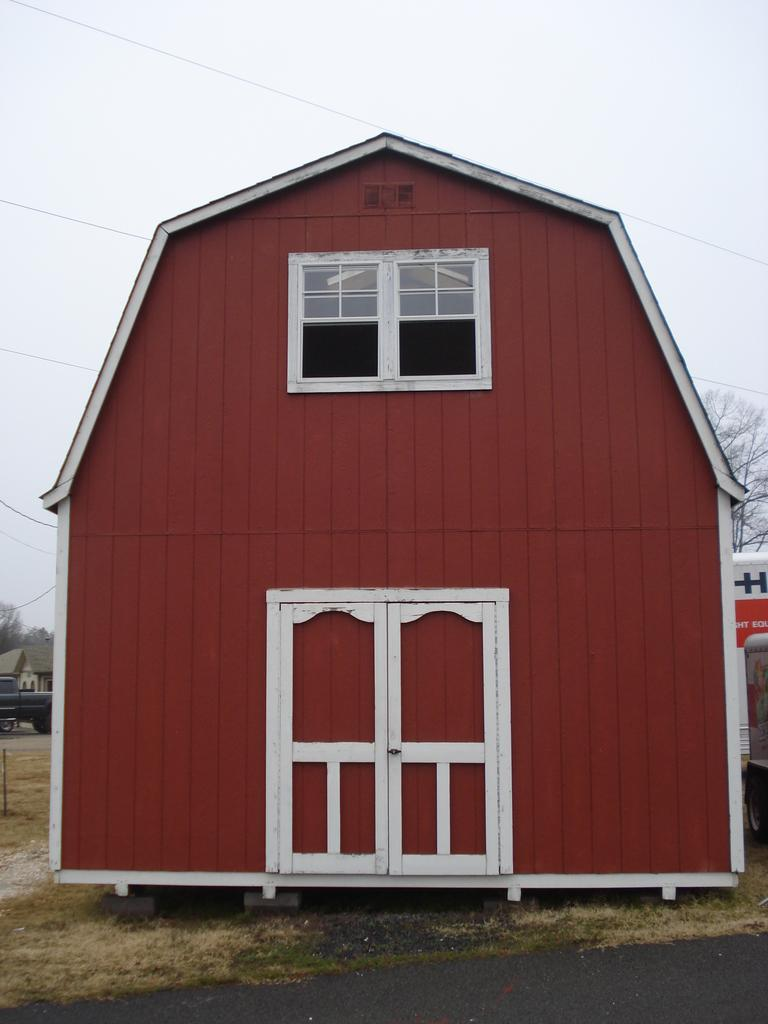What is the main structure in the front of the image? There is a house in the front of the image. What can be seen in the background of the image? There are trees and vehicles in the background of the image. What is the condition of the sky in the image? The sky is cloudy in the image. What is present at the top of the image? There are wires at the top of the image. Can you see any veins in the image? There are no veins present in the image; it features a house, trees, vehicles, a cloudy sky, and wires. 